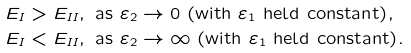Convert formula to latex. <formula><loc_0><loc_0><loc_500><loc_500>& E _ { I } > E _ { I I } , \text { as } \varepsilon _ { 2 } \to 0 \text { (with $\varepsilon_{1}$ held constant)} , \\ & E _ { I } < E _ { I I } , \text { as } \varepsilon _ { 2 } \to \infty \text { (with $\varepsilon_{1}$ held constant)} .</formula> 